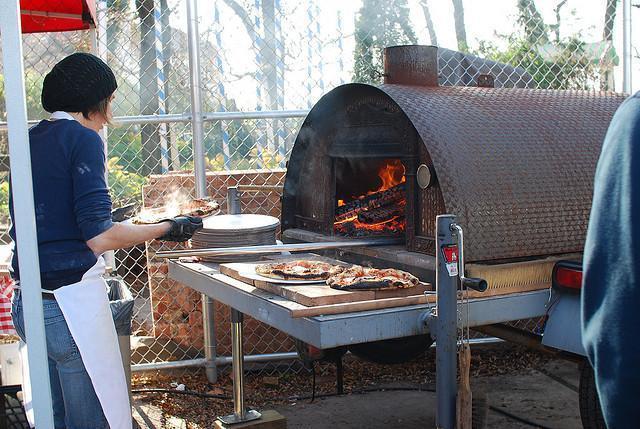How many bike on this image?
Give a very brief answer. 0. 